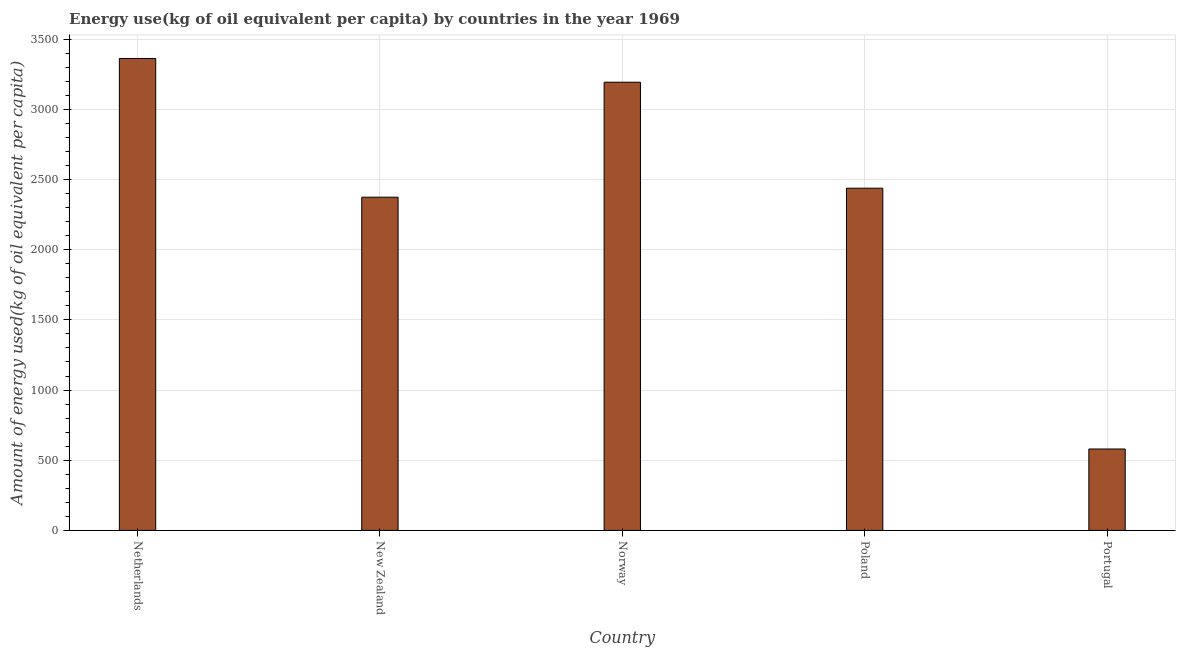Does the graph contain any zero values?
Keep it short and to the point. No. Does the graph contain grids?
Your answer should be very brief. Yes. What is the title of the graph?
Offer a terse response. Energy use(kg of oil equivalent per capita) by countries in the year 1969. What is the label or title of the X-axis?
Your response must be concise. Country. What is the label or title of the Y-axis?
Your answer should be compact. Amount of energy used(kg of oil equivalent per capita). What is the amount of energy used in Norway?
Make the answer very short. 3193.66. Across all countries, what is the maximum amount of energy used?
Your answer should be compact. 3362.79. Across all countries, what is the minimum amount of energy used?
Your answer should be compact. 579.97. In which country was the amount of energy used maximum?
Make the answer very short. Netherlands. In which country was the amount of energy used minimum?
Your response must be concise. Portugal. What is the sum of the amount of energy used?
Provide a succinct answer. 1.19e+04. What is the difference between the amount of energy used in Netherlands and Portugal?
Make the answer very short. 2782.82. What is the average amount of energy used per country?
Offer a terse response. 2389.8. What is the median amount of energy used?
Your answer should be compact. 2438.37. In how many countries, is the amount of energy used greater than 900 kg?
Offer a very short reply. 4. What is the ratio of the amount of energy used in Netherlands to that in New Zealand?
Offer a very short reply. 1.42. Is the amount of energy used in Poland less than that in Portugal?
Give a very brief answer. No. Is the difference between the amount of energy used in Norway and Portugal greater than the difference between any two countries?
Offer a terse response. No. What is the difference between the highest and the second highest amount of energy used?
Offer a terse response. 169.13. What is the difference between the highest and the lowest amount of energy used?
Offer a very short reply. 2782.81. What is the difference between two consecutive major ticks on the Y-axis?
Give a very brief answer. 500. Are the values on the major ticks of Y-axis written in scientific E-notation?
Ensure brevity in your answer.  No. What is the Amount of energy used(kg of oil equivalent per capita) of Netherlands?
Make the answer very short. 3362.79. What is the Amount of energy used(kg of oil equivalent per capita) in New Zealand?
Your answer should be compact. 2374.23. What is the Amount of energy used(kg of oil equivalent per capita) of Norway?
Your response must be concise. 3193.66. What is the Amount of energy used(kg of oil equivalent per capita) in Poland?
Your answer should be very brief. 2438.37. What is the Amount of energy used(kg of oil equivalent per capita) in Portugal?
Your answer should be compact. 579.97. What is the difference between the Amount of energy used(kg of oil equivalent per capita) in Netherlands and New Zealand?
Provide a short and direct response. 988.56. What is the difference between the Amount of energy used(kg of oil equivalent per capita) in Netherlands and Norway?
Keep it short and to the point. 169.13. What is the difference between the Amount of energy used(kg of oil equivalent per capita) in Netherlands and Poland?
Offer a terse response. 924.42. What is the difference between the Amount of energy used(kg of oil equivalent per capita) in Netherlands and Portugal?
Give a very brief answer. 2782.81. What is the difference between the Amount of energy used(kg of oil equivalent per capita) in New Zealand and Norway?
Your answer should be very brief. -819.43. What is the difference between the Amount of energy used(kg of oil equivalent per capita) in New Zealand and Poland?
Your response must be concise. -64.14. What is the difference between the Amount of energy used(kg of oil equivalent per capita) in New Zealand and Portugal?
Offer a very short reply. 1794.26. What is the difference between the Amount of energy used(kg of oil equivalent per capita) in Norway and Poland?
Make the answer very short. 755.29. What is the difference between the Amount of energy used(kg of oil equivalent per capita) in Norway and Portugal?
Give a very brief answer. 2613.68. What is the difference between the Amount of energy used(kg of oil equivalent per capita) in Poland and Portugal?
Your response must be concise. 1858.39. What is the ratio of the Amount of energy used(kg of oil equivalent per capita) in Netherlands to that in New Zealand?
Provide a succinct answer. 1.42. What is the ratio of the Amount of energy used(kg of oil equivalent per capita) in Netherlands to that in Norway?
Ensure brevity in your answer.  1.05. What is the ratio of the Amount of energy used(kg of oil equivalent per capita) in Netherlands to that in Poland?
Ensure brevity in your answer.  1.38. What is the ratio of the Amount of energy used(kg of oil equivalent per capita) in Netherlands to that in Portugal?
Offer a terse response. 5.8. What is the ratio of the Amount of energy used(kg of oil equivalent per capita) in New Zealand to that in Norway?
Your response must be concise. 0.74. What is the ratio of the Amount of energy used(kg of oil equivalent per capita) in New Zealand to that in Portugal?
Your answer should be very brief. 4.09. What is the ratio of the Amount of energy used(kg of oil equivalent per capita) in Norway to that in Poland?
Offer a very short reply. 1.31. What is the ratio of the Amount of energy used(kg of oil equivalent per capita) in Norway to that in Portugal?
Your answer should be very brief. 5.51. What is the ratio of the Amount of energy used(kg of oil equivalent per capita) in Poland to that in Portugal?
Your response must be concise. 4.2. 